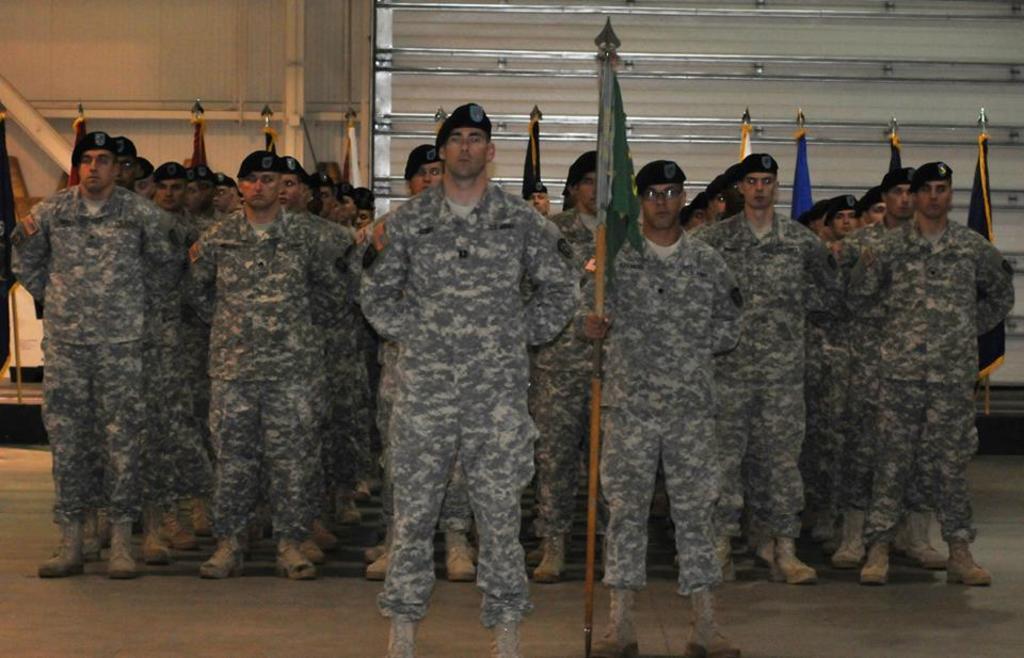Please provide a concise description of this image. In this image there are people standing on a floor, holding flags in their hand, in the background there is a wall. 